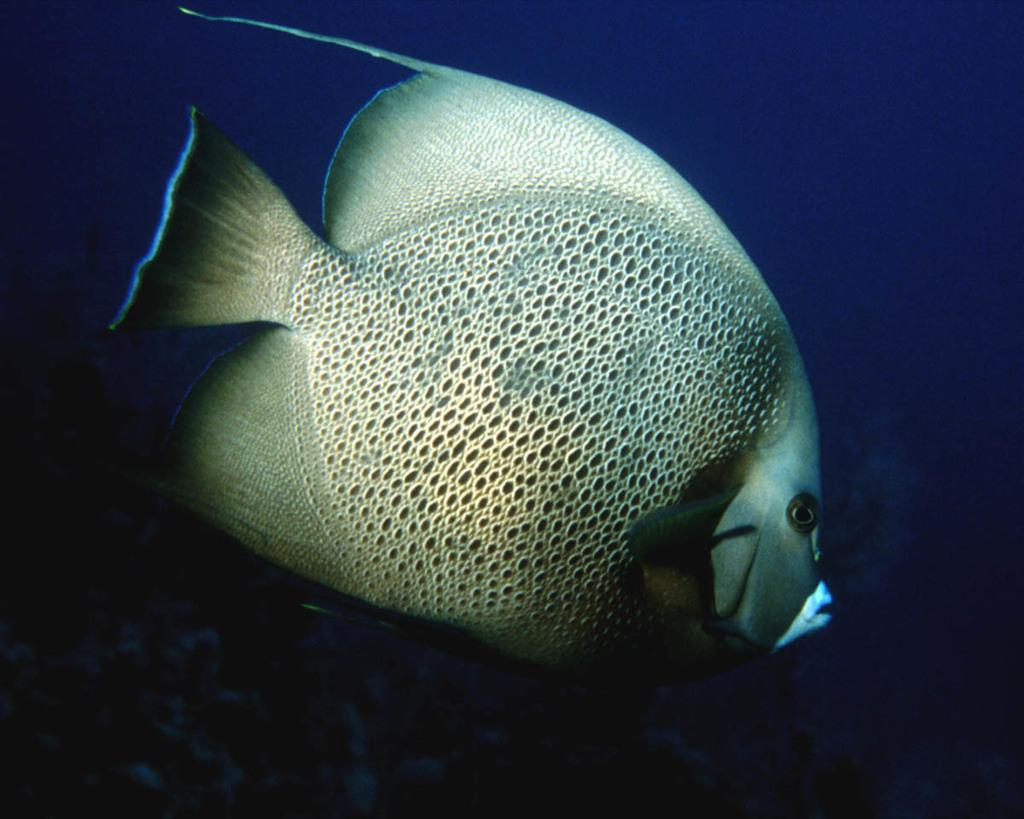What is the main subject of the image? There is a fish in the image. What color is the background of the image? The background of the image is blue. How does the fish stretch its body in the image? The image does not show the fish stretching its body, as it is a still image. What type of mark can be seen on the fish in the image? There are no marks visible on the fish in the image. 